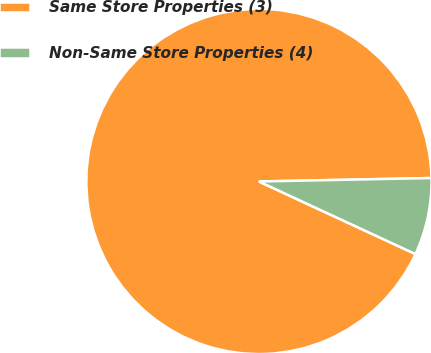Convert chart. <chart><loc_0><loc_0><loc_500><loc_500><pie_chart><fcel>Same Store Properties (3)<fcel>Non-Same Store Properties (4)<nl><fcel>92.77%<fcel>7.23%<nl></chart> 